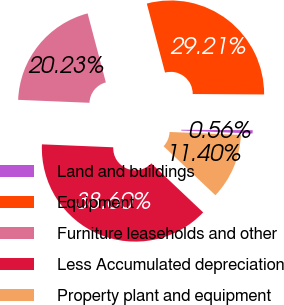Convert chart to OTSL. <chart><loc_0><loc_0><loc_500><loc_500><pie_chart><fcel>Land and buildings<fcel>Equipment<fcel>Furniture leaseholds and other<fcel>Less Accumulated depreciation<fcel>Property plant and equipment<nl><fcel>0.56%<fcel>29.21%<fcel>20.23%<fcel>38.6%<fcel>11.4%<nl></chart> 